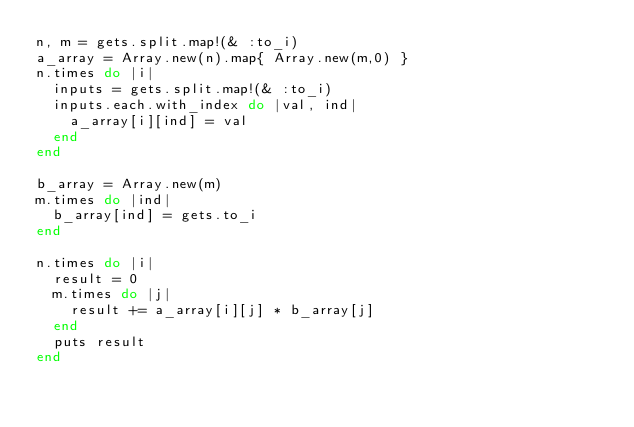<code> <loc_0><loc_0><loc_500><loc_500><_Ruby_>n, m = gets.split.map!(& :to_i)
a_array = Array.new(n).map{ Array.new(m,0) }
n.times do |i|
  inputs = gets.split.map!(& :to_i)
  inputs.each.with_index do |val, ind|
  	a_array[i][ind] = val
  end
end

b_array = Array.new(m)
m.times do |ind|
  b_array[ind] = gets.to_i
end

n.times do |i|
  result = 0
  m.times do |j|
  	result += a_array[i][j] * b_array[j]  	
  end
  puts result
end</code> 